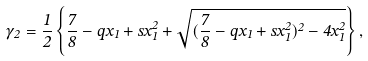Convert formula to latex. <formula><loc_0><loc_0><loc_500><loc_500>\gamma _ { 2 } = \frac { 1 } { 2 } \left \{ \frac { 7 } { 8 } - q x _ { 1 } + s x _ { 1 } ^ { 2 } + \sqrt { ( \frac { 7 } { 8 } - q x _ { 1 } + s x _ { 1 } ^ { 2 } ) ^ { 2 } - 4 x _ { 1 } ^ { 2 } } \right \} ,</formula> 